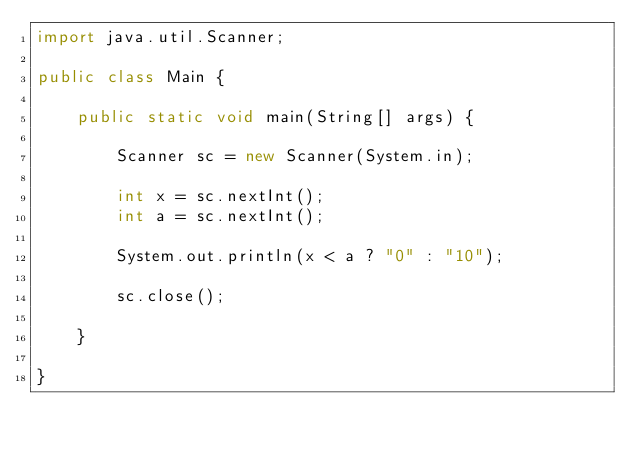Convert code to text. <code><loc_0><loc_0><loc_500><loc_500><_Java_>import java.util.Scanner;

public class Main {

	public static void main(String[] args) {

		Scanner sc = new Scanner(System.in);

		int x = sc.nextInt();
		int a = sc.nextInt();

		System.out.println(x < a ? "0" : "10");

		sc.close();

	}

}
</code> 